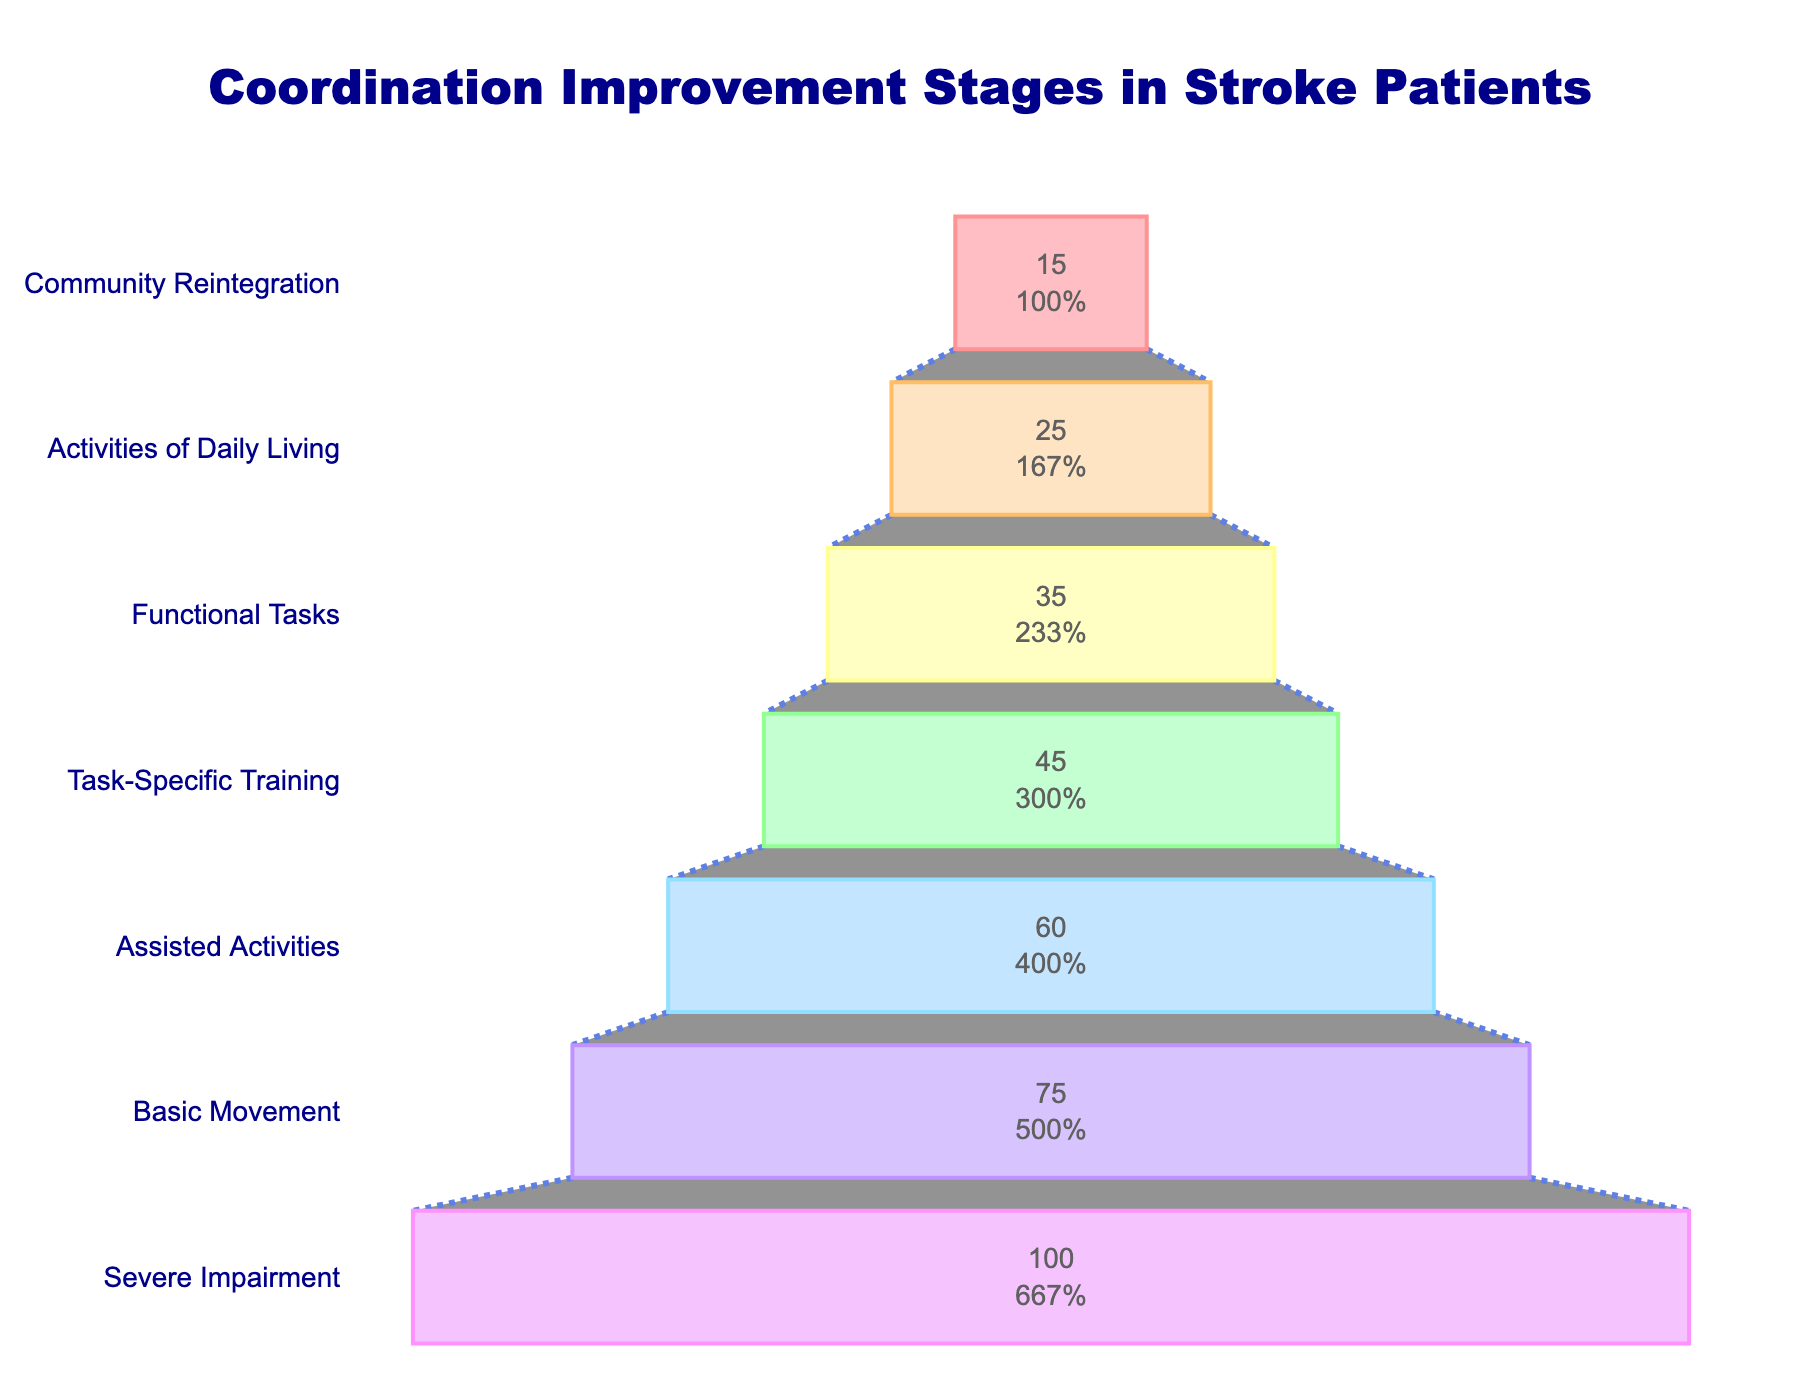What's the title of the funnel chart? Look at the top of the chart to find the title. The title is prominently displayed and easy to locate.
Answer: "Coordination Improvement Stages in Stroke Patients" How many stages are shown in the funnel chart? Count the number of distinct stages listed on the left side of the chart.
Answer: 7 Which stage has the highest number of patients? Find the stage at the widest part (top) of the funnel, as the width represents the number of patients.
Answer: Severe Impairment Which stage has the least number of patients? Locate the narrowest part (bottom) of the funnel, representing the lowest number of patients.
Answer: Community Reintegration What is the difference in the number of patients between 'Severe Impairment' and 'Basic Movement'? Subtract the number of patients in 'Basic Movement' from 'Severe Impairment'. 100 - 75 = 25
Answer: 25 What percentage of patients in the 'Basic Movement' stage achieve 'Task-Specific Training'? Calculate by finding the percentage of 'Task-Specific Training' patients out of 'Basic Movement' patients: (45/75) × 100% ≈ 60%
Answer: 60% How many more patients are there in 'Functional Tasks' compared to 'Activities of Daily Living'? Subtract the number of patients in 'Activities of Daily Living' from 'Functional Tasks'. 35 - 25 = 10
Answer: 10 Which stage shows a transition with the smallest decrease in the number of patients from the previous stage? Compare the differences in patient numbers between consecutive stages, the smallest decrease is between 'Activities of Daily Living' (25) and 'Community Reintegration' (15).
Answer: Community Reintegration What is the total number of patients from 'Severe Impairment' to 'Community Reintegration'? Sum the number of patients in all stages. 100 + 75 + 60 + 45 + 35 + 25 + 15 = 355
Answer: 355 What is the average number of patients across all stages? Calculate the mean by dividing the total number of patients by the number of stages. 355 / 7 ≈ 50.7
Answer: 50.7 